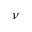Convert formula to latex. <formula><loc_0><loc_0><loc_500><loc_500>\nu</formula> 